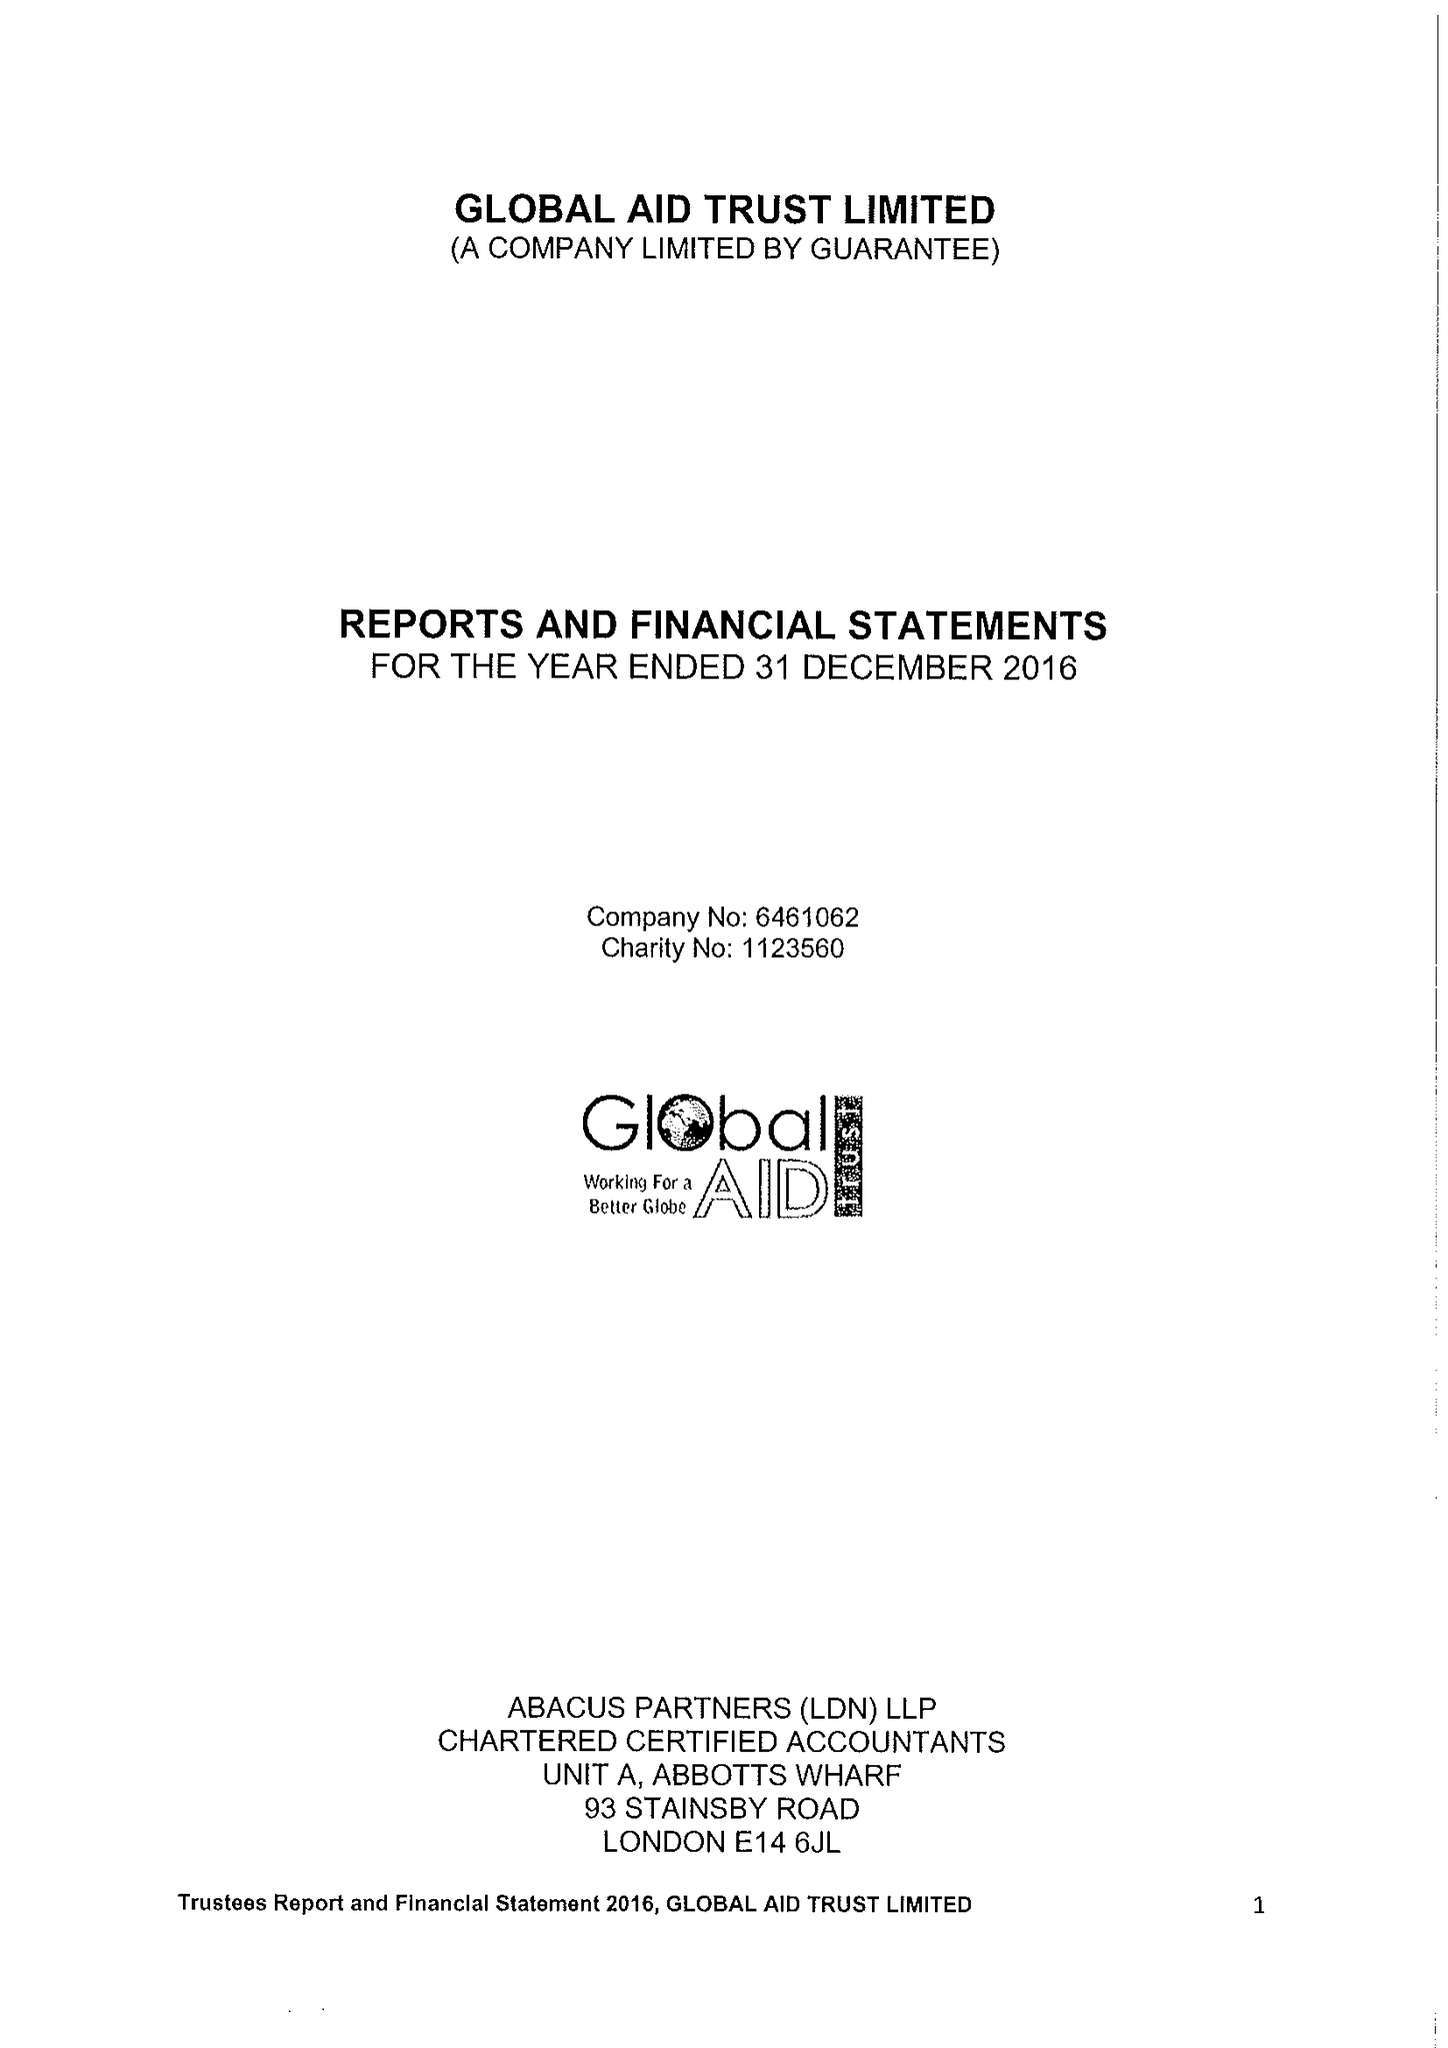What is the value for the report_date?
Answer the question using a single word or phrase. 2016-12-31 